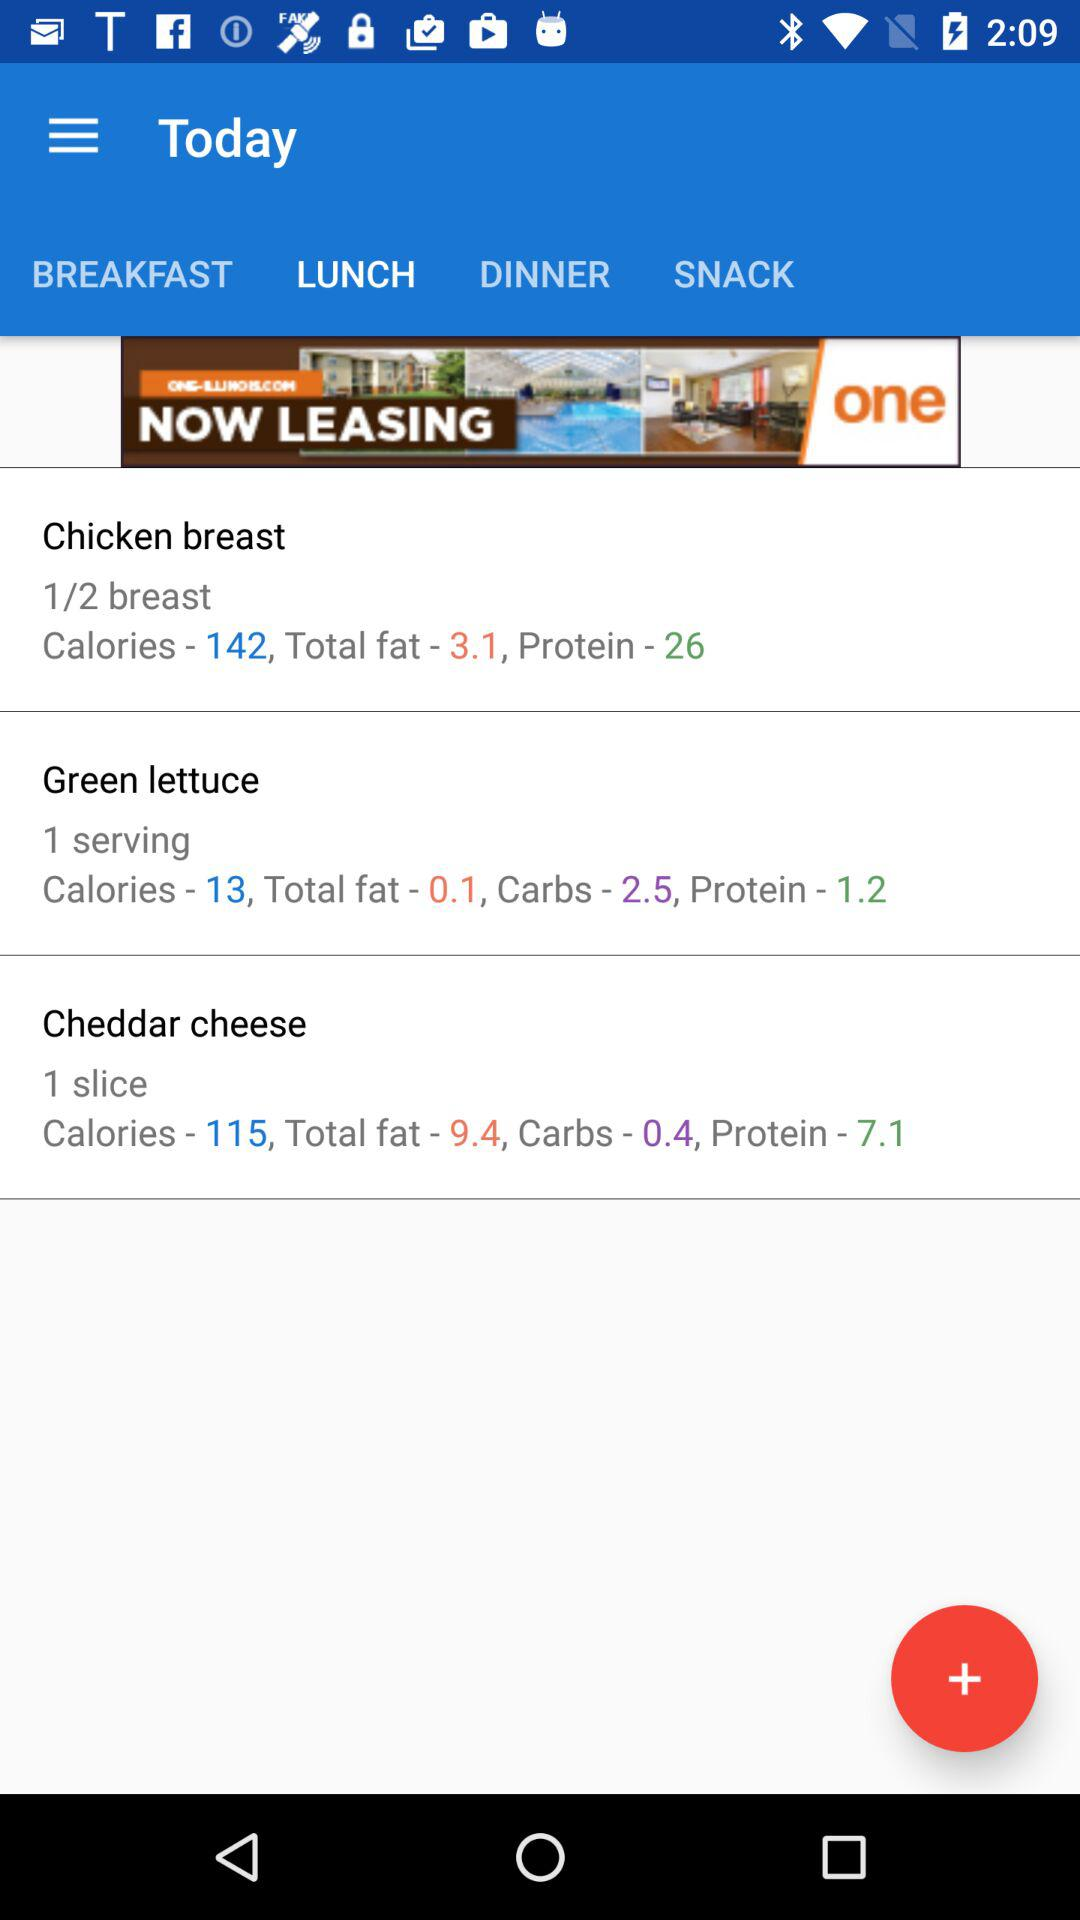Which tab is selected? The selected tab is "LUNCH". 